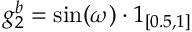<formula> <loc_0><loc_0><loc_500><loc_500>g _ { 2 } ^ { b } = \sin ( \omega ) \cdot 1 _ { [ 0 . 5 , 1 ] }</formula> 